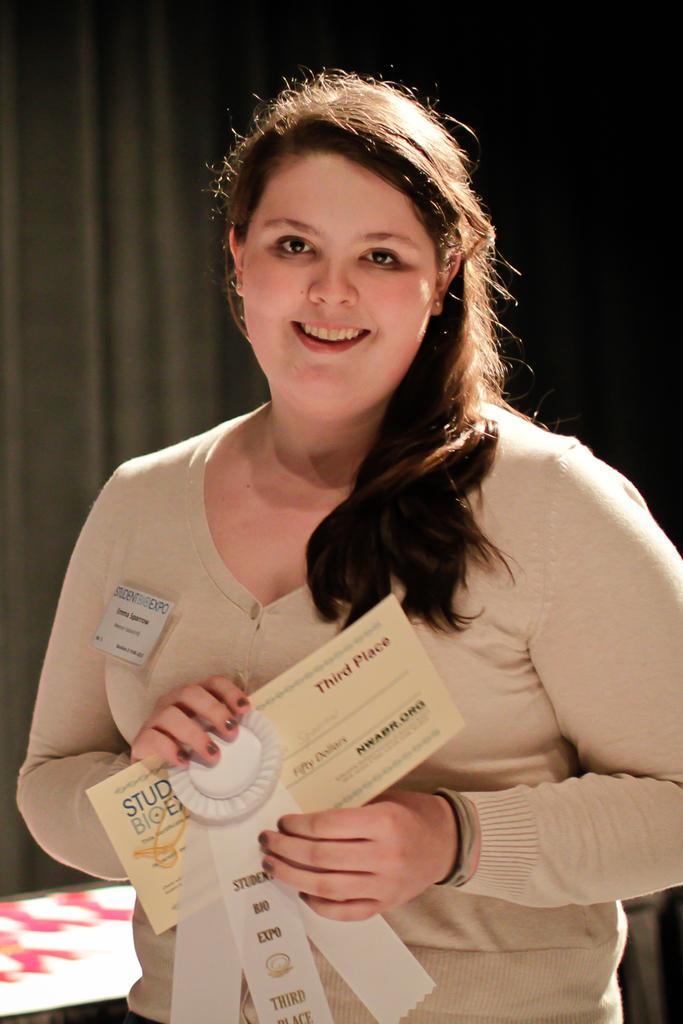In one or two sentences, can you explain what this image depicts? In this image we can see a person wearing cream color sweatshirt holding some certificate in her hands and at the background of the image there is black color sheet. 